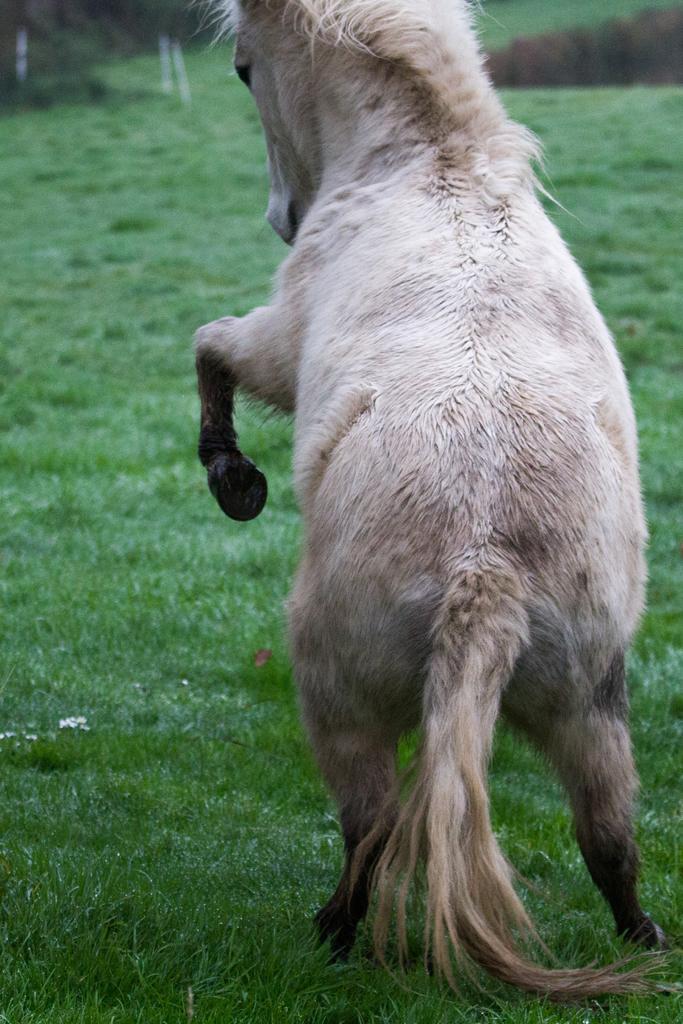Please provide a concise description of this image. In the center of the image a horse is there. In the background of the image grass is present. 